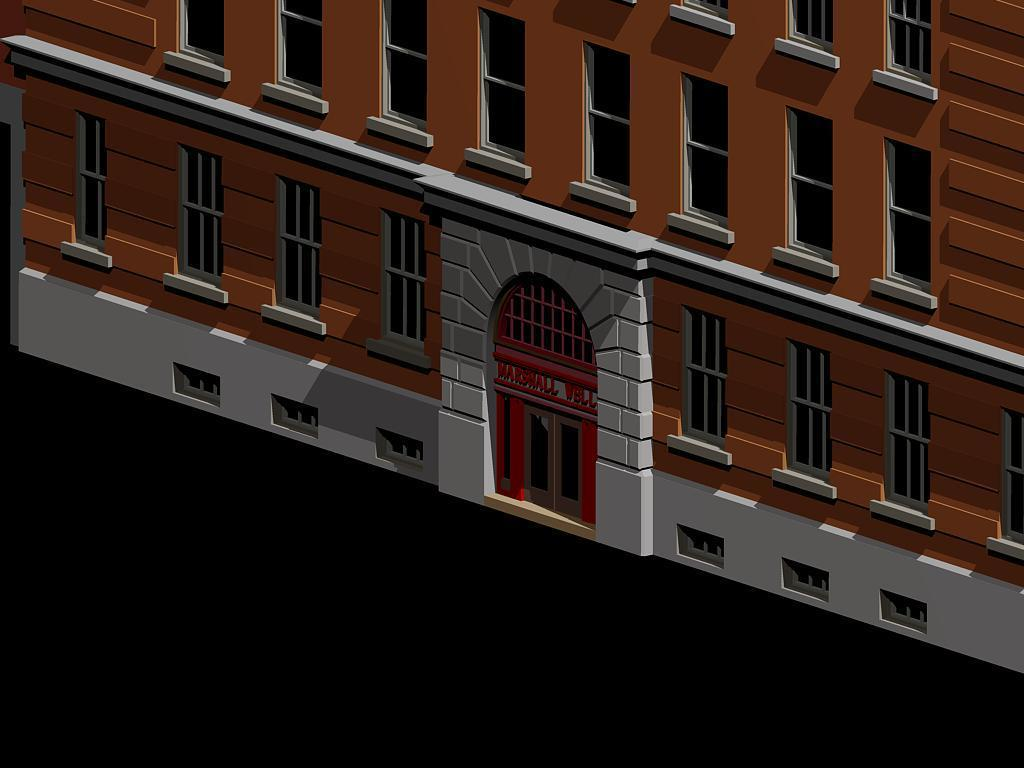What type of structure is present in the image? There is a building in the image. What architectural features can be seen on the building? The building has windows and doors. Is there any text visible in the image? Yes, there is text visible in the image. Can you see a tramp in the wilderness adjusting the text in the image? There is no tramp or wilderness present in the image. The image only features a building with windows, doors, and text. 